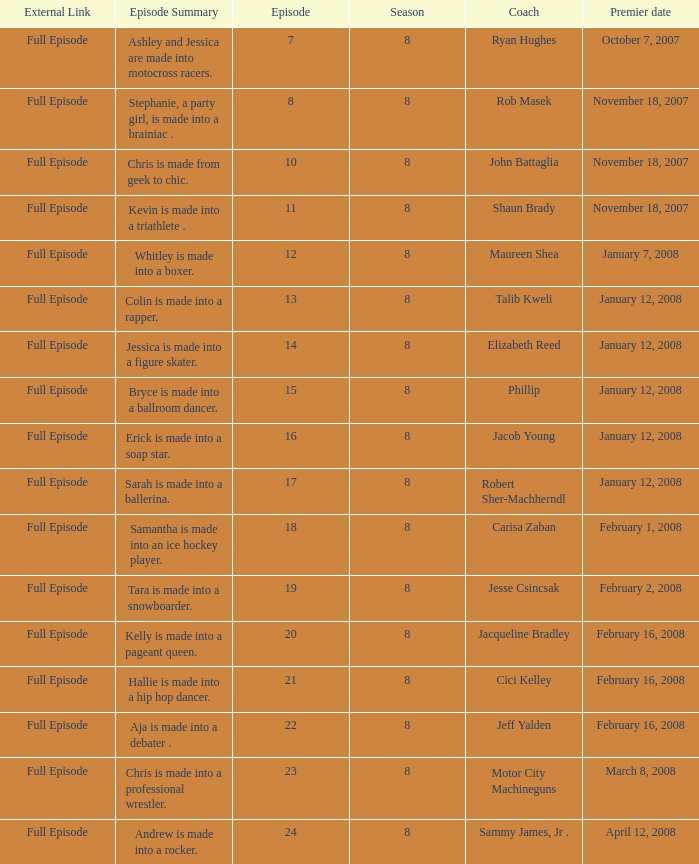What coach premiered February 16, 2008 later than episode 21.0? Jeff Yalden. 